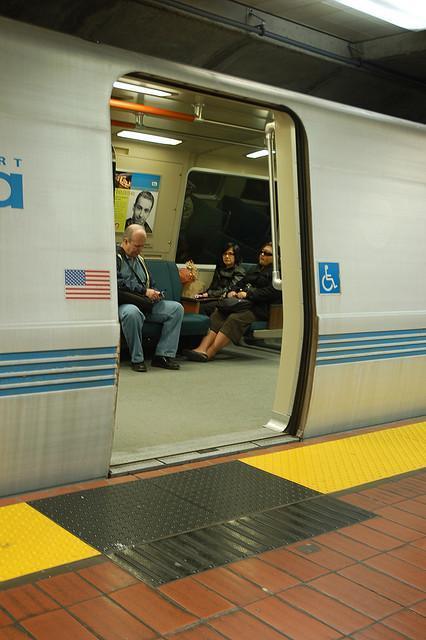How many people can be seen?
Give a very brief answer. 2. How many zebras are in the photo?
Give a very brief answer. 0. 